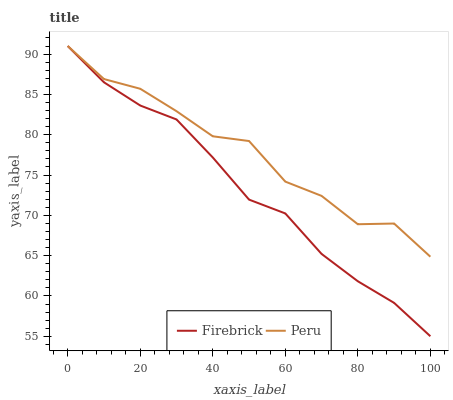Does Firebrick have the minimum area under the curve?
Answer yes or no. Yes. Does Peru have the maximum area under the curve?
Answer yes or no. Yes. Does Peru have the minimum area under the curve?
Answer yes or no. No. Is Firebrick the smoothest?
Answer yes or no. Yes. Is Peru the roughest?
Answer yes or no. Yes. Is Peru the smoothest?
Answer yes or no. No. Does Firebrick have the lowest value?
Answer yes or no. Yes. Does Peru have the lowest value?
Answer yes or no. No. Does Peru have the highest value?
Answer yes or no. Yes. Does Firebrick intersect Peru?
Answer yes or no. Yes. Is Firebrick less than Peru?
Answer yes or no. No. Is Firebrick greater than Peru?
Answer yes or no. No. 